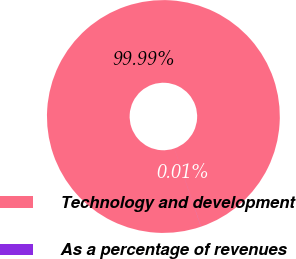<chart> <loc_0><loc_0><loc_500><loc_500><pie_chart><fcel>Technology and development<fcel>As a percentage of revenues<nl><fcel>99.99%<fcel>0.01%<nl></chart> 